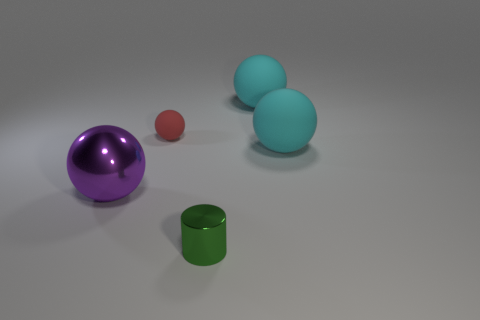How do the sizes of the different objects compare? There are various sized objects in the image. The purple sphere is the largest, followed by two identical blue spheres of medium size. The red sphere is the smallest, and the green cylinder also has a small size relative to the other objects. 